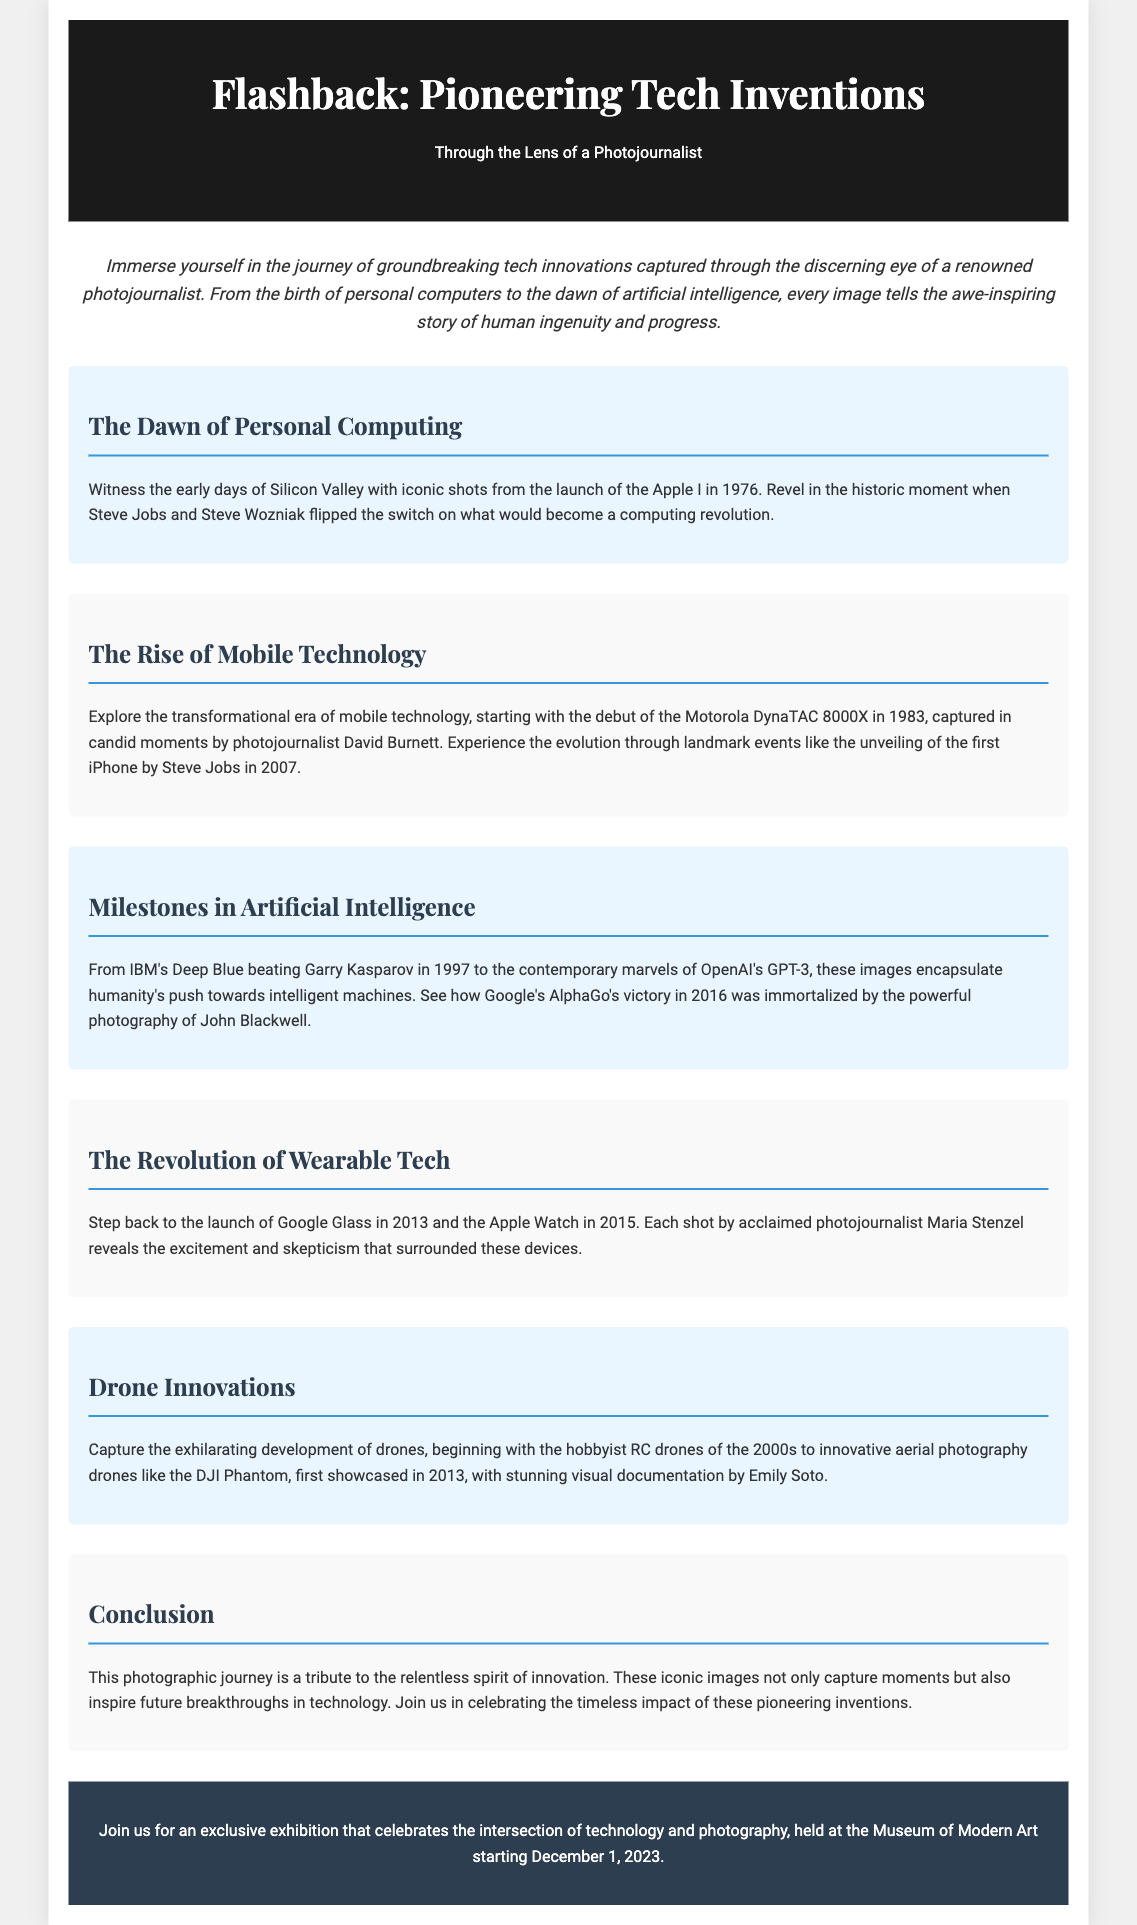What year was the Apple I launched? The document states that the Apple I was launched in 1976.
Answer: 1976 Who captured the images of the Motorola DynaTAC 8000X launch? The flyer mentions that the candid moments of the Motorola DynaTAC 8000X were captured by photojournalist David Burnett.
Answer: David Burnett What technology was launched in 2013? The section mentions the launch of Google Glass in 2013.
Answer: Google Glass Which competition did IBM's Deep Blue win? IBM's Deep Blue beat Garry Kasparov in 1997, as stated in the document.
Answer: Garry Kasparov What is the theme of the exhibition mentioned in the footer? The footer highlights that the exhibition celebrates the intersection of technology and photography.
Answer: Technology and photography Which two wearable technologies are discussed in the document? The document discusses Google Glass and the Apple Watch.
Answer: Google Glass, Apple Watch What year did Google Glass launch? The document specifies the launch year of Google Glass as 2013.
Answer: 2013 Who is the photojournalist associated with the launch of the Apple Watch? The document does not explicitly mention a photojournalist for the Apple Watch, making this an insight-based question.
Answer: Not specified What is the name of the aerial photography drone showcased in 2013? The document refers to the DJI Phantom as the aerial photography drone first showcased in 2013.
Answer: DJI Phantom 